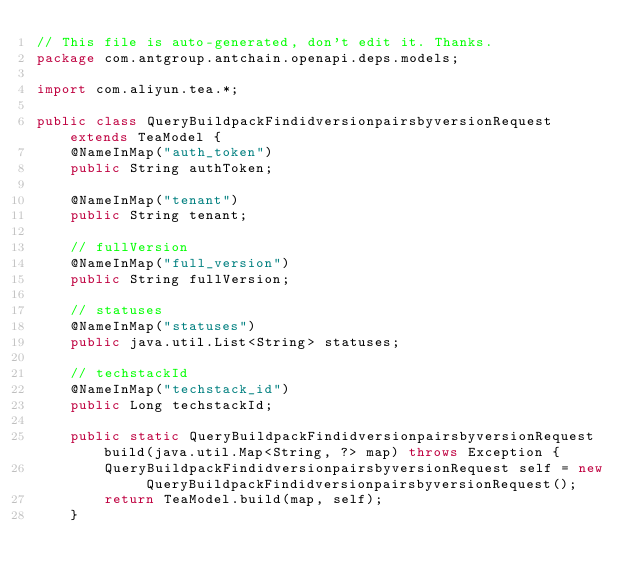Convert code to text. <code><loc_0><loc_0><loc_500><loc_500><_Java_>// This file is auto-generated, don't edit it. Thanks.
package com.antgroup.antchain.openapi.deps.models;

import com.aliyun.tea.*;

public class QueryBuildpackFindidversionpairsbyversionRequest extends TeaModel {
    @NameInMap("auth_token")
    public String authToken;

    @NameInMap("tenant")
    public String tenant;

    // fullVersion
    @NameInMap("full_version")
    public String fullVersion;

    // statuses
    @NameInMap("statuses")
    public java.util.List<String> statuses;

    // techstackId
    @NameInMap("techstack_id")
    public Long techstackId;

    public static QueryBuildpackFindidversionpairsbyversionRequest build(java.util.Map<String, ?> map) throws Exception {
        QueryBuildpackFindidversionpairsbyversionRequest self = new QueryBuildpackFindidversionpairsbyversionRequest();
        return TeaModel.build(map, self);
    }
</code> 